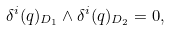<formula> <loc_0><loc_0><loc_500><loc_500>\delta ^ { i } ( q ) _ { D _ { 1 } } \wedge \delta ^ { i } ( q ) _ { D _ { 2 } } = 0 ,</formula> 